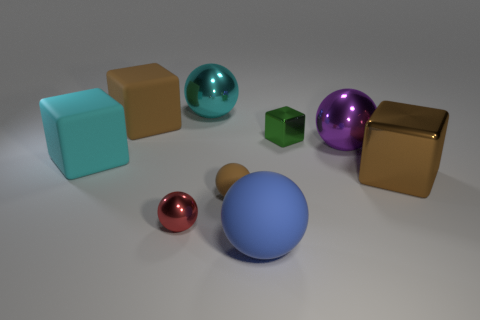Subtract all brown spheres. How many spheres are left? 4 Subtract all gray spheres. Subtract all yellow blocks. How many spheres are left? 5 Subtract all spheres. How many objects are left? 4 Subtract all big blue spheres. Subtract all red shiny balls. How many objects are left? 7 Add 3 big cubes. How many big cubes are left? 6 Add 4 cyan matte cubes. How many cyan matte cubes exist? 5 Subtract 0 blue cylinders. How many objects are left? 9 